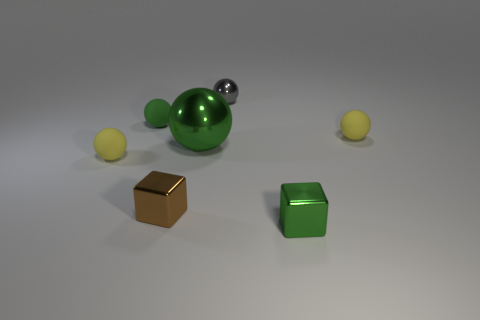Subtract all small green rubber balls. How many balls are left? 4 Subtract all green balls. How many balls are left? 3 Subtract all gray spheres. Subtract all blue cylinders. How many spheres are left? 4 Add 1 big spheres. How many objects exist? 8 Subtract all blocks. How many objects are left? 5 Add 6 small metallic blocks. How many small metallic blocks are left? 8 Add 3 tiny brown shiny cubes. How many tiny brown shiny cubes exist? 4 Subtract 0 gray cylinders. How many objects are left? 7 Subtract all tiny gray shiny spheres. Subtract all big balls. How many objects are left? 5 